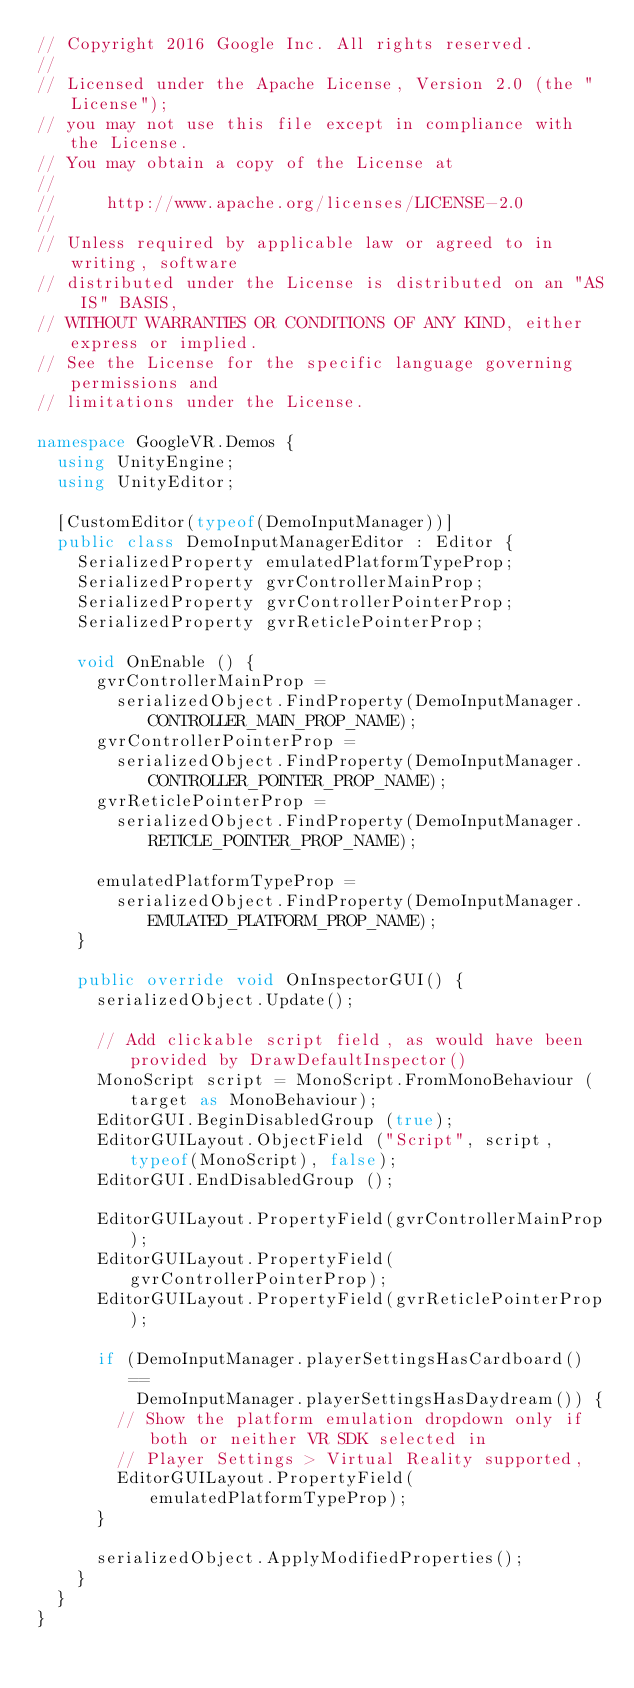Convert code to text. <code><loc_0><loc_0><loc_500><loc_500><_C#_>// Copyright 2016 Google Inc. All rights reserved.
//
// Licensed under the Apache License, Version 2.0 (the "License");
// you may not use this file except in compliance with the License.
// You may obtain a copy of the License at
//
//     http://www.apache.org/licenses/LICENSE-2.0
//
// Unless required by applicable law or agreed to in writing, software
// distributed under the License is distributed on an "AS IS" BASIS,
// WITHOUT WARRANTIES OR CONDITIONS OF ANY KIND, either express or implied.
// See the License for the specific language governing permissions and
// limitations under the License.

namespace GoogleVR.Demos {
  using UnityEngine;
  using UnityEditor;

  [CustomEditor(typeof(DemoInputManager))]
  public class DemoInputManagerEditor : Editor {
    SerializedProperty emulatedPlatformTypeProp;
    SerializedProperty gvrControllerMainProp;
    SerializedProperty gvrControllerPointerProp;
    SerializedProperty gvrReticlePointerProp;

    void OnEnable () {
      gvrControllerMainProp =
        serializedObject.FindProperty(DemoInputManager.CONTROLLER_MAIN_PROP_NAME);
      gvrControllerPointerProp =
        serializedObject.FindProperty(DemoInputManager.CONTROLLER_POINTER_PROP_NAME);
      gvrReticlePointerProp =
        serializedObject.FindProperty(DemoInputManager.RETICLE_POINTER_PROP_NAME);

      emulatedPlatformTypeProp =
        serializedObject.FindProperty(DemoInputManager.EMULATED_PLATFORM_PROP_NAME);
    }

    public override void OnInspectorGUI() {
      serializedObject.Update();

      // Add clickable script field, as would have been provided by DrawDefaultInspector()
      MonoScript script = MonoScript.FromMonoBehaviour (target as MonoBehaviour);
      EditorGUI.BeginDisabledGroup (true);
      EditorGUILayout.ObjectField ("Script", script, typeof(MonoScript), false);
      EditorGUI.EndDisabledGroup ();

      EditorGUILayout.PropertyField(gvrControllerMainProp);
      EditorGUILayout.PropertyField(gvrControllerPointerProp);
      EditorGUILayout.PropertyField(gvrReticlePointerProp);

      if (DemoInputManager.playerSettingsHasCardboard() ==
          DemoInputManager.playerSettingsHasDaydream()) {
        // Show the platform emulation dropdown only if both or neither VR SDK selected in
        // Player Settings > Virtual Reality supported,
        EditorGUILayout.PropertyField(emulatedPlatformTypeProp);
      }

      serializedObject.ApplyModifiedProperties();
    }
  }
}
</code> 